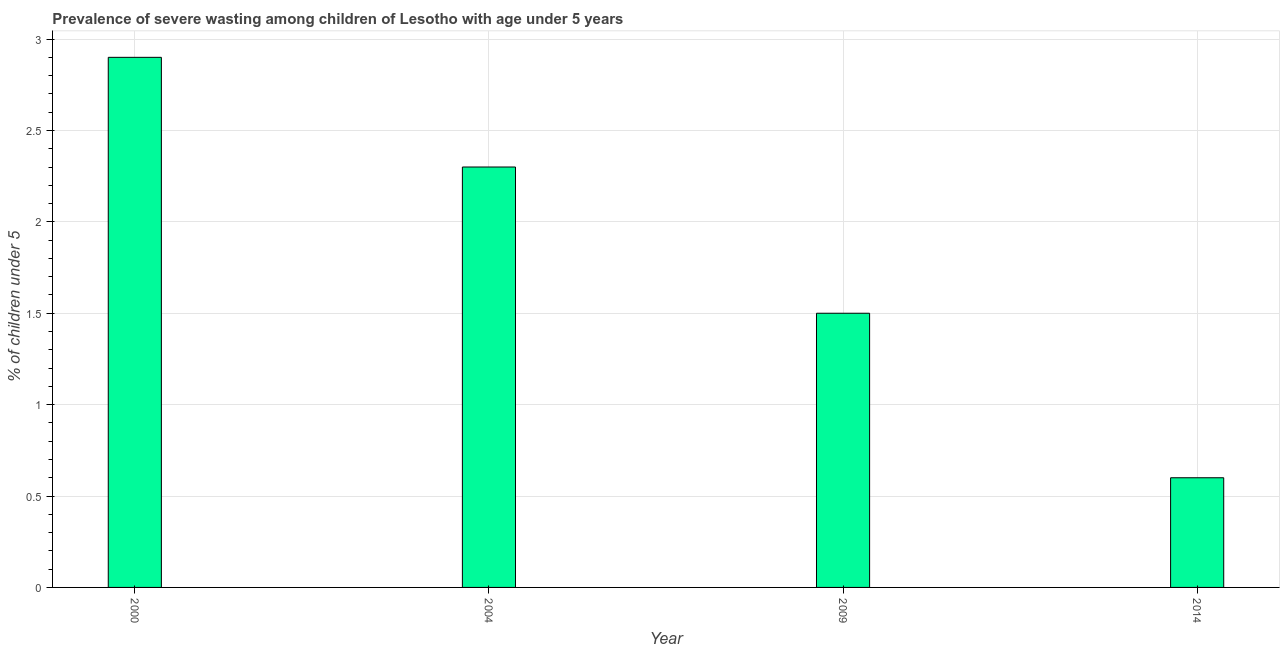What is the title of the graph?
Provide a succinct answer. Prevalence of severe wasting among children of Lesotho with age under 5 years. What is the label or title of the Y-axis?
Offer a very short reply.  % of children under 5. What is the prevalence of severe wasting in 2014?
Your answer should be compact. 0.6. Across all years, what is the maximum prevalence of severe wasting?
Your answer should be very brief. 2.9. Across all years, what is the minimum prevalence of severe wasting?
Give a very brief answer. 0.6. In which year was the prevalence of severe wasting maximum?
Keep it short and to the point. 2000. What is the sum of the prevalence of severe wasting?
Make the answer very short. 7.3. What is the average prevalence of severe wasting per year?
Provide a short and direct response. 1.82. What is the median prevalence of severe wasting?
Ensure brevity in your answer.  1.9. In how many years, is the prevalence of severe wasting greater than 0.3 %?
Give a very brief answer. 4. Do a majority of the years between 2009 and 2004 (inclusive) have prevalence of severe wasting greater than 2.5 %?
Make the answer very short. No. What is the ratio of the prevalence of severe wasting in 2004 to that in 2014?
Offer a terse response. 3.83. Is the difference between the prevalence of severe wasting in 2004 and 2014 greater than the difference between any two years?
Give a very brief answer. No. What is the difference between the highest and the second highest prevalence of severe wasting?
Make the answer very short. 0.6. In how many years, is the prevalence of severe wasting greater than the average prevalence of severe wasting taken over all years?
Offer a terse response. 2. Are all the bars in the graph horizontal?
Make the answer very short. No. How many years are there in the graph?
Your answer should be compact. 4. What is the difference between two consecutive major ticks on the Y-axis?
Provide a succinct answer. 0.5. Are the values on the major ticks of Y-axis written in scientific E-notation?
Provide a succinct answer. No. What is the  % of children under 5 of 2000?
Offer a terse response. 2.9. What is the  % of children under 5 in 2004?
Provide a short and direct response. 2.3. What is the  % of children under 5 in 2014?
Ensure brevity in your answer.  0.6. What is the difference between the  % of children under 5 in 2000 and 2009?
Make the answer very short. 1.4. What is the difference between the  % of children under 5 in 2000 and 2014?
Your answer should be very brief. 2.3. What is the difference between the  % of children under 5 in 2004 and 2009?
Provide a short and direct response. 0.8. What is the difference between the  % of children under 5 in 2004 and 2014?
Your response must be concise. 1.7. What is the difference between the  % of children under 5 in 2009 and 2014?
Keep it short and to the point. 0.9. What is the ratio of the  % of children under 5 in 2000 to that in 2004?
Give a very brief answer. 1.26. What is the ratio of the  % of children under 5 in 2000 to that in 2009?
Your answer should be very brief. 1.93. What is the ratio of the  % of children under 5 in 2000 to that in 2014?
Keep it short and to the point. 4.83. What is the ratio of the  % of children under 5 in 2004 to that in 2009?
Make the answer very short. 1.53. What is the ratio of the  % of children under 5 in 2004 to that in 2014?
Provide a succinct answer. 3.83. 